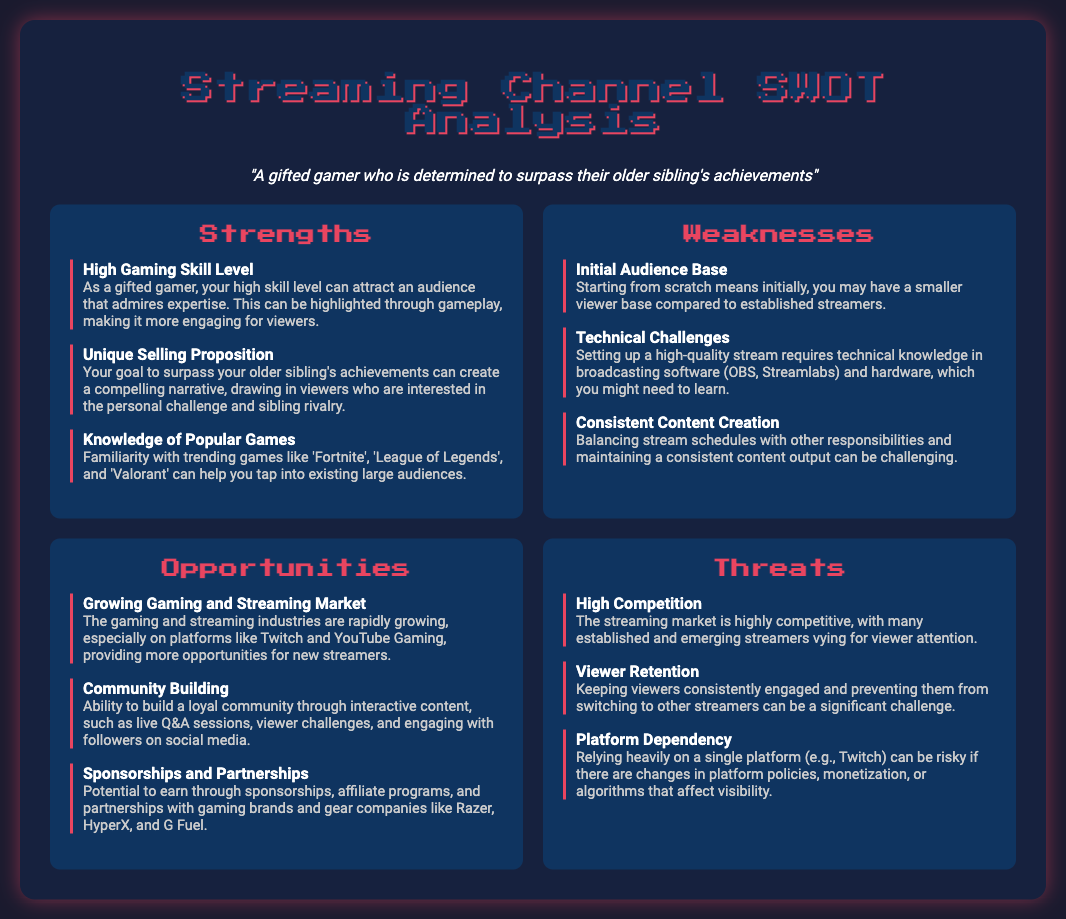What is the title of the document? The title appears at the top of the document, which is "Streaming Channel SWOT Analysis."
Answer: Streaming Channel SWOT Analysis What primary skill level does the document highlight as a strength? The document notes that a gifted gamer has a "High Gaming Skill Level" as a strength in content creation.
Answer: High Gaming Skill Level What is one of the weaknesses mentioned regarding content creation? One of the weaknesses discussed is "Initial Audience Base," indicating starting with a smaller viewer base.
Answer: Initial Audience Base What opportunity involves engaging with followers? The document states that "Community Building" is an opportunity to create interactive content with viewers.
Answer: Community Building What is a threat related to competition? The document lists "High Competition" as a threat faced in the streaming market.
Answer: High Competition What percentage of document sections is dedicated to strengths? The document has four sections: strengths, weaknesses, opportunities, threats; thus, strengths make up 25%.
Answer: 25% Which gaming platform is mentioned as an opportunity? The document refers to "Twitch" and "YouTube Gaming" as platforms providing opportunities for new streamers.
Answer: Twitch and YouTube Gaming What are potential earnings sources listed in the opportunities? The potential earnings from "sponsorships, affiliate programs, and partnerships" with gaming brands are outlined.
Answer: sponsorships, affiliate programs, and partnerships What is a significant challenge mentioned in viewer retention? The document highlights that "keeping viewers consistently engaged" is a challenge for content creators.
Answer: keeping viewers consistently engaged 